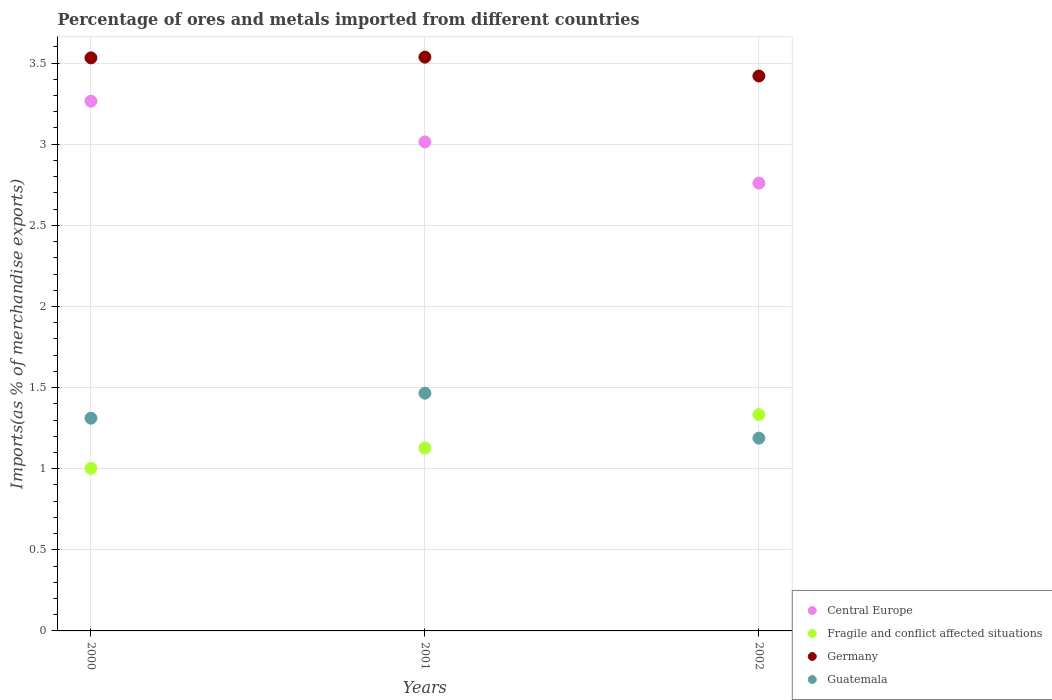How many different coloured dotlines are there?
Ensure brevity in your answer.  4. Is the number of dotlines equal to the number of legend labels?
Make the answer very short. Yes. What is the percentage of imports to different countries in Fragile and conflict affected situations in 2000?
Make the answer very short. 1. Across all years, what is the maximum percentage of imports to different countries in Central Europe?
Keep it short and to the point. 3.27. Across all years, what is the minimum percentage of imports to different countries in Fragile and conflict affected situations?
Your response must be concise. 1. In which year was the percentage of imports to different countries in Guatemala maximum?
Your answer should be compact. 2001. What is the total percentage of imports to different countries in Central Europe in the graph?
Your answer should be very brief. 9.04. What is the difference between the percentage of imports to different countries in Central Europe in 2000 and that in 2001?
Your answer should be compact. 0.25. What is the difference between the percentage of imports to different countries in Fragile and conflict affected situations in 2002 and the percentage of imports to different countries in Central Europe in 2000?
Ensure brevity in your answer.  -1.93. What is the average percentage of imports to different countries in Guatemala per year?
Ensure brevity in your answer.  1.32. In the year 2001, what is the difference between the percentage of imports to different countries in Fragile and conflict affected situations and percentage of imports to different countries in Guatemala?
Make the answer very short. -0.34. What is the ratio of the percentage of imports to different countries in Guatemala in 2001 to that in 2002?
Ensure brevity in your answer.  1.23. Is the percentage of imports to different countries in Central Europe in 2000 less than that in 2001?
Ensure brevity in your answer.  No. Is the difference between the percentage of imports to different countries in Fragile and conflict affected situations in 2000 and 2002 greater than the difference between the percentage of imports to different countries in Guatemala in 2000 and 2002?
Offer a terse response. No. What is the difference between the highest and the second highest percentage of imports to different countries in Fragile and conflict affected situations?
Ensure brevity in your answer.  0.21. What is the difference between the highest and the lowest percentage of imports to different countries in Fragile and conflict affected situations?
Offer a very short reply. 0.33. Is it the case that in every year, the sum of the percentage of imports to different countries in Fragile and conflict affected situations and percentage of imports to different countries in Central Europe  is greater than the sum of percentage of imports to different countries in Germany and percentage of imports to different countries in Guatemala?
Keep it short and to the point. Yes. Is it the case that in every year, the sum of the percentage of imports to different countries in Germany and percentage of imports to different countries in Fragile and conflict affected situations  is greater than the percentage of imports to different countries in Central Europe?
Keep it short and to the point. Yes. Does the percentage of imports to different countries in Guatemala monotonically increase over the years?
Your answer should be very brief. No. Is the percentage of imports to different countries in Guatemala strictly less than the percentage of imports to different countries in Fragile and conflict affected situations over the years?
Make the answer very short. No. How many dotlines are there?
Your response must be concise. 4. How many years are there in the graph?
Provide a succinct answer. 3. Does the graph contain any zero values?
Your answer should be compact. No. Does the graph contain grids?
Your answer should be compact. Yes. How are the legend labels stacked?
Your response must be concise. Vertical. What is the title of the graph?
Provide a short and direct response. Percentage of ores and metals imported from different countries. Does "Sweden" appear as one of the legend labels in the graph?
Ensure brevity in your answer.  No. What is the label or title of the X-axis?
Your answer should be compact. Years. What is the label or title of the Y-axis?
Keep it short and to the point. Imports(as % of merchandise exports). What is the Imports(as % of merchandise exports) in Central Europe in 2000?
Give a very brief answer. 3.27. What is the Imports(as % of merchandise exports) in Fragile and conflict affected situations in 2000?
Offer a very short reply. 1. What is the Imports(as % of merchandise exports) of Germany in 2000?
Your answer should be compact. 3.53. What is the Imports(as % of merchandise exports) of Guatemala in 2000?
Make the answer very short. 1.31. What is the Imports(as % of merchandise exports) of Central Europe in 2001?
Your response must be concise. 3.01. What is the Imports(as % of merchandise exports) in Fragile and conflict affected situations in 2001?
Keep it short and to the point. 1.13. What is the Imports(as % of merchandise exports) in Germany in 2001?
Keep it short and to the point. 3.54. What is the Imports(as % of merchandise exports) of Guatemala in 2001?
Offer a very short reply. 1.47. What is the Imports(as % of merchandise exports) in Central Europe in 2002?
Ensure brevity in your answer.  2.76. What is the Imports(as % of merchandise exports) in Fragile and conflict affected situations in 2002?
Offer a very short reply. 1.33. What is the Imports(as % of merchandise exports) in Germany in 2002?
Offer a terse response. 3.42. What is the Imports(as % of merchandise exports) in Guatemala in 2002?
Ensure brevity in your answer.  1.19. Across all years, what is the maximum Imports(as % of merchandise exports) of Central Europe?
Your response must be concise. 3.27. Across all years, what is the maximum Imports(as % of merchandise exports) of Fragile and conflict affected situations?
Your response must be concise. 1.33. Across all years, what is the maximum Imports(as % of merchandise exports) in Germany?
Your answer should be compact. 3.54. Across all years, what is the maximum Imports(as % of merchandise exports) in Guatemala?
Keep it short and to the point. 1.47. Across all years, what is the minimum Imports(as % of merchandise exports) in Central Europe?
Give a very brief answer. 2.76. Across all years, what is the minimum Imports(as % of merchandise exports) of Fragile and conflict affected situations?
Ensure brevity in your answer.  1. Across all years, what is the minimum Imports(as % of merchandise exports) in Germany?
Offer a terse response. 3.42. Across all years, what is the minimum Imports(as % of merchandise exports) of Guatemala?
Provide a succinct answer. 1.19. What is the total Imports(as % of merchandise exports) in Central Europe in the graph?
Give a very brief answer. 9.04. What is the total Imports(as % of merchandise exports) of Fragile and conflict affected situations in the graph?
Give a very brief answer. 3.46. What is the total Imports(as % of merchandise exports) in Germany in the graph?
Provide a succinct answer. 10.49. What is the total Imports(as % of merchandise exports) in Guatemala in the graph?
Ensure brevity in your answer.  3.97. What is the difference between the Imports(as % of merchandise exports) in Central Europe in 2000 and that in 2001?
Your answer should be very brief. 0.25. What is the difference between the Imports(as % of merchandise exports) of Fragile and conflict affected situations in 2000 and that in 2001?
Ensure brevity in your answer.  -0.13. What is the difference between the Imports(as % of merchandise exports) in Germany in 2000 and that in 2001?
Make the answer very short. -0. What is the difference between the Imports(as % of merchandise exports) in Guatemala in 2000 and that in 2001?
Your answer should be compact. -0.15. What is the difference between the Imports(as % of merchandise exports) in Central Europe in 2000 and that in 2002?
Provide a succinct answer. 0.51. What is the difference between the Imports(as % of merchandise exports) in Fragile and conflict affected situations in 2000 and that in 2002?
Provide a succinct answer. -0.33. What is the difference between the Imports(as % of merchandise exports) in Germany in 2000 and that in 2002?
Offer a very short reply. 0.11. What is the difference between the Imports(as % of merchandise exports) in Guatemala in 2000 and that in 2002?
Make the answer very short. 0.12. What is the difference between the Imports(as % of merchandise exports) in Central Europe in 2001 and that in 2002?
Provide a short and direct response. 0.25. What is the difference between the Imports(as % of merchandise exports) in Fragile and conflict affected situations in 2001 and that in 2002?
Give a very brief answer. -0.21. What is the difference between the Imports(as % of merchandise exports) of Germany in 2001 and that in 2002?
Provide a short and direct response. 0.12. What is the difference between the Imports(as % of merchandise exports) in Guatemala in 2001 and that in 2002?
Your response must be concise. 0.28. What is the difference between the Imports(as % of merchandise exports) in Central Europe in 2000 and the Imports(as % of merchandise exports) in Fragile and conflict affected situations in 2001?
Make the answer very short. 2.14. What is the difference between the Imports(as % of merchandise exports) of Central Europe in 2000 and the Imports(as % of merchandise exports) of Germany in 2001?
Make the answer very short. -0.27. What is the difference between the Imports(as % of merchandise exports) of Central Europe in 2000 and the Imports(as % of merchandise exports) of Guatemala in 2001?
Your response must be concise. 1.8. What is the difference between the Imports(as % of merchandise exports) of Fragile and conflict affected situations in 2000 and the Imports(as % of merchandise exports) of Germany in 2001?
Provide a short and direct response. -2.53. What is the difference between the Imports(as % of merchandise exports) in Fragile and conflict affected situations in 2000 and the Imports(as % of merchandise exports) in Guatemala in 2001?
Offer a very short reply. -0.46. What is the difference between the Imports(as % of merchandise exports) in Germany in 2000 and the Imports(as % of merchandise exports) in Guatemala in 2001?
Offer a very short reply. 2.07. What is the difference between the Imports(as % of merchandise exports) in Central Europe in 2000 and the Imports(as % of merchandise exports) in Fragile and conflict affected situations in 2002?
Ensure brevity in your answer.  1.93. What is the difference between the Imports(as % of merchandise exports) in Central Europe in 2000 and the Imports(as % of merchandise exports) in Germany in 2002?
Your response must be concise. -0.16. What is the difference between the Imports(as % of merchandise exports) in Central Europe in 2000 and the Imports(as % of merchandise exports) in Guatemala in 2002?
Provide a short and direct response. 2.08. What is the difference between the Imports(as % of merchandise exports) of Fragile and conflict affected situations in 2000 and the Imports(as % of merchandise exports) of Germany in 2002?
Ensure brevity in your answer.  -2.42. What is the difference between the Imports(as % of merchandise exports) of Fragile and conflict affected situations in 2000 and the Imports(as % of merchandise exports) of Guatemala in 2002?
Your answer should be compact. -0.19. What is the difference between the Imports(as % of merchandise exports) of Germany in 2000 and the Imports(as % of merchandise exports) of Guatemala in 2002?
Make the answer very short. 2.34. What is the difference between the Imports(as % of merchandise exports) of Central Europe in 2001 and the Imports(as % of merchandise exports) of Fragile and conflict affected situations in 2002?
Ensure brevity in your answer.  1.68. What is the difference between the Imports(as % of merchandise exports) in Central Europe in 2001 and the Imports(as % of merchandise exports) in Germany in 2002?
Provide a succinct answer. -0.41. What is the difference between the Imports(as % of merchandise exports) in Central Europe in 2001 and the Imports(as % of merchandise exports) in Guatemala in 2002?
Provide a short and direct response. 1.83. What is the difference between the Imports(as % of merchandise exports) in Fragile and conflict affected situations in 2001 and the Imports(as % of merchandise exports) in Germany in 2002?
Make the answer very short. -2.29. What is the difference between the Imports(as % of merchandise exports) in Fragile and conflict affected situations in 2001 and the Imports(as % of merchandise exports) in Guatemala in 2002?
Give a very brief answer. -0.06. What is the difference between the Imports(as % of merchandise exports) in Germany in 2001 and the Imports(as % of merchandise exports) in Guatemala in 2002?
Make the answer very short. 2.35. What is the average Imports(as % of merchandise exports) of Central Europe per year?
Your response must be concise. 3.01. What is the average Imports(as % of merchandise exports) of Fragile and conflict affected situations per year?
Ensure brevity in your answer.  1.15. What is the average Imports(as % of merchandise exports) in Germany per year?
Make the answer very short. 3.5. What is the average Imports(as % of merchandise exports) of Guatemala per year?
Keep it short and to the point. 1.32. In the year 2000, what is the difference between the Imports(as % of merchandise exports) of Central Europe and Imports(as % of merchandise exports) of Fragile and conflict affected situations?
Your answer should be very brief. 2.26. In the year 2000, what is the difference between the Imports(as % of merchandise exports) of Central Europe and Imports(as % of merchandise exports) of Germany?
Offer a very short reply. -0.27. In the year 2000, what is the difference between the Imports(as % of merchandise exports) in Central Europe and Imports(as % of merchandise exports) in Guatemala?
Give a very brief answer. 1.95. In the year 2000, what is the difference between the Imports(as % of merchandise exports) in Fragile and conflict affected situations and Imports(as % of merchandise exports) in Germany?
Make the answer very short. -2.53. In the year 2000, what is the difference between the Imports(as % of merchandise exports) of Fragile and conflict affected situations and Imports(as % of merchandise exports) of Guatemala?
Ensure brevity in your answer.  -0.31. In the year 2000, what is the difference between the Imports(as % of merchandise exports) of Germany and Imports(as % of merchandise exports) of Guatemala?
Your response must be concise. 2.22. In the year 2001, what is the difference between the Imports(as % of merchandise exports) in Central Europe and Imports(as % of merchandise exports) in Fragile and conflict affected situations?
Your answer should be compact. 1.89. In the year 2001, what is the difference between the Imports(as % of merchandise exports) of Central Europe and Imports(as % of merchandise exports) of Germany?
Provide a short and direct response. -0.52. In the year 2001, what is the difference between the Imports(as % of merchandise exports) of Central Europe and Imports(as % of merchandise exports) of Guatemala?
Offer a terse response. 1.55. In the year 2001, what is the difference between the Imports(as % of merchandise exports) of Fragile and conflict affected situations and Imports(as % of merchandise exports) of Germany?
Your answer should be compact. -2.41. In the year 2001, what is the difference between the Imports(as % of merchandise exports) of Fragile and conflict affected situations and Imports(as % of merchandise exports) of Guatemala?
Provide a succinct answer. -0.34. In the year 2001, what is the difference between the Imports(as % of merchandise exports) of Germany and Imports(as % of merchandise exports) of Guatemala?
Ensure brevity in your answer.  2.07. In the year 2002, what is the difference between the Imports(as % of merchandise exports) in Central Europe and Imports(as % of merchandise exports) in Fragile and conflict affected situations?
Offer a terse response. 1.43. In the year 2002, what is the difference between the Imports(as % of merchandise exports) in Central Europe and Imports(as % of merchandise exports) in Germany?
Make the answer very short. -0.66. In the year 2002, what is the difference between the Imports(as % of merchandise exports) of Central Europe and Imports(as % of merchandise exports) of Guatemala?
Keep it short and to the point. 1.57. In the year 2002, what is the difference between the Imports(as % of merchandise exports) in Fragile and conflict affected situations and Imports(as % of merchandise exports) in Germany?
Your answer should be compact. -2.09. In the year 2002, what is the difference between the Imports(as % of merchandise exports) of Fragile and conflict affected situations and Imports(as % of merchandise exports) of Guatemala?
Ensure brevity in your answer.  0.14. In the year 2002, what is the difference between the Imports(as % of merchandise exports) of Germany and Imports(as % of merchandise exports) of Guatemala?
Your answer should be compact. 2.23. What is the ratio of the Imports(as % of merchandise exports) in Central Europe in 2000 to that in 2001?
Give a very brief answer. 1.08. What is the ratio of the Imports(as % of merchandise exports) in Fragile and conflict affected situations in 2000 to that in 2001?
Your answer should be compact. 0.89. What is the ratio of the Imports(as % of merchandise exports) in Germany in 2000 to that in 2001?
Offer a very short reply. 1. What is the ratio of the Imports(as % of merchandise exports) in Guatemala in 2000 to that in 2001?
Your response must be concise. 0.89. What is the ratio of the Imports(as % of merchandise exports) of Central Europe in 2000 to that in 2002?
Offer a very short reply. 1.18. What is the ratio of the Imports(as % of merchandise exports) in Fragile and conflict affected situations in 2000 to that in 2002?
Your answer should be compact. 0.75. What is the ratio of the Imports(as % of merchandise exports) of Germany in 2000 to that in 2002?
Your answer should be very brief. 1.03. What is the ratio of the Imports(as % of merchandise exports) of Guatemala in 2000 to that in 2002?
Your answer should be very brief. 1.1. What is the ratio of the Imports(as % of merchandise exports) of Central Europe in 2001 to that in 2002?
Keep it short and to the point. 1.09. What is the ratio of the Imports(as % of merchandise exports) of Fragile and conflict affected situations in 2001 to that in 2002?
Offer a very short reply. 0.85. What is the ratio of the Imports(as % of merchandise exports) in Germany in 2001 to that in 2002?
Make the answer very short. 1.03. What is the ratio of the Imports(as % of merchandise exports) in Guatemala in 2001 to that in 2002?
Keep it short and to the point. 1.23. What is the difference between the highest and the second highest Imports(as % of merchandise exports) in Central Europe?
Your response must be concise. 0.25. What is the difference between the highest and the second highest Imports(as % of merchandise exports) in Fragile and conflict affected situations?
Offer a very short reply. 0.21. What is the difference between the highest and the second highest Imports(as % of merchandise exports) in Germany?
Keep it short and to the point. 0. What is the difference between the highest and the second highest Imports(as % of merchandise exports) of Guatemala?
Ensure brevity in your answer.  0.15. What is the difference between the highest and the lowest Imports(as % of merchandise exports) in Central Europe?
Your answer should be very brief. 0.51. What is the difference between the highest and the lowest Imports(as % of merchandise exports) in Fragile and conflict affected situations?
Make the answer very short. 0.33. What is the difference between the highest and the lowest Imports(as % of merchandise exports) in Germany?
Your answer should be compact. 0.12. What is the difference between the highest and the lowest Imports(as % of merchandise exports) of Guatemala?
Provide a short and direct response. 0.28. 